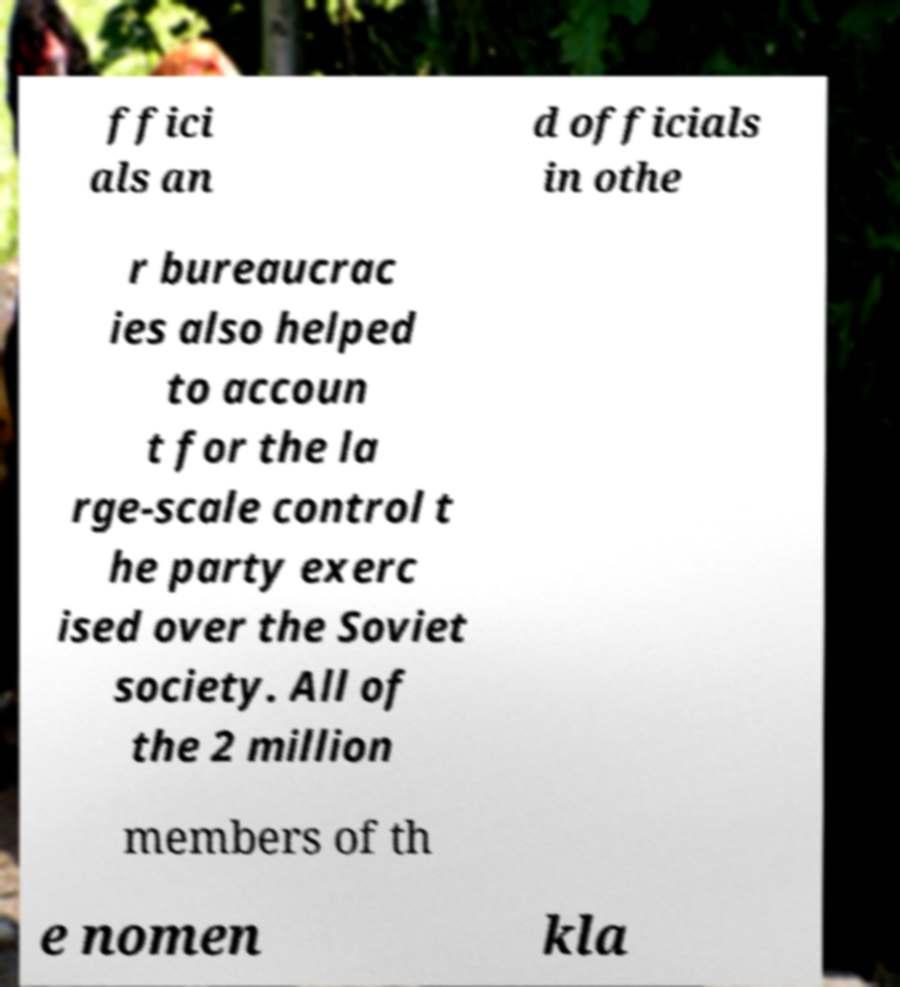I need the written content from this picture converted into text. Can you do that? ffici als an d officials in othe r bureaucrac ies also helped to accoun t for the la rge-scale control t he party exerc ised over the Soviet society. All of the 2 million members of th e nomen kla 